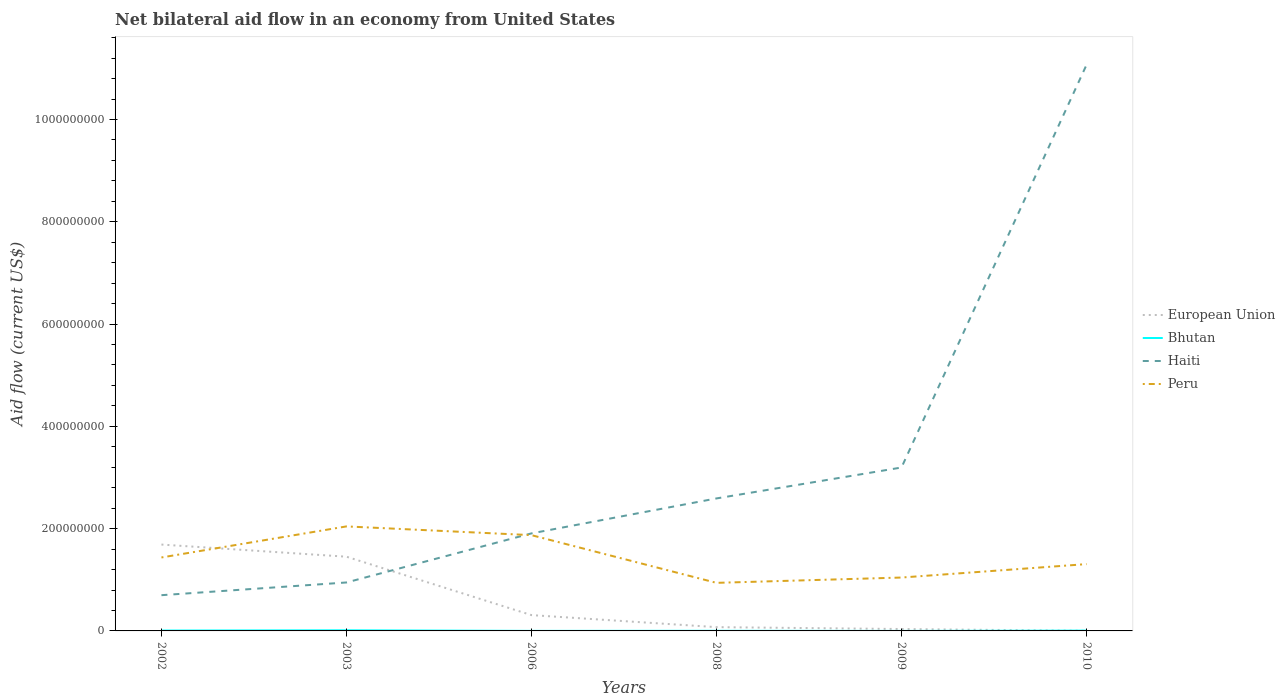Is the number of lines equal to the number of legend labels?
Your answer should be compact. Yes. Across all years, what is the maximum net bilateral aid flow in Peru?
Keep it short and to the point. 9.40e+07. What is the total net bilateral aid flow in European Union in the graph?
Make the answer very short. 1.38e+08. What is the difference between the highest and the second highest net bilateral aid flow in European Union?
Offer a very short reply. 1.69e+08. Is the net bilateral aid flow in Bhutan strictly greater than the net bilateral aid flow in European Union over the years?
Provide a short and direct response. No. How many years are there in the graph?
Keep it short and to the point. 6. Are the values on the major ticks of Y-axis written in scientific E-notation?
Make the answer very short. No. Does the graph contain any zero values?
Your answer should be very brief. No. How many legend labels are there?
Make the answer very short. 4. How are the legend labels stacked?
Give a very brief answer. Vertical. What is the title of the graph?
Your answer should be compact. Net bilateral aid flow in an economy from United States. Does "Hong Kong" appear as one of the legend labels in the graph?
Give a very brief answer. No. What is the label or title of the X-axis?
Give a very brief answer. Years. What is the label or title of the Y-axis?
Offer a very short reply. Aid flow (current US$). What is the Aid flow (current US$) in European Union in 2002?
Provide a short and direct response. 1.69e+08. What is the Aid flow (current US$) in Bhutan in 2002?
Ensure brevity in your answer.  7.30e+05. What is the Aid flow (current US$) of Haiti in 2002?
Give a very brief answer. 6.99e+07. What is the Aid flow (current US$) of Peru in 2002?
Provide a short and direct response. 1.44e+08. What is the Aid flow (current US$) of European Union in 2003?
Your answer should be compact. 1.45e+08. What is the Aid flow (current US$) of Bhutan in 2003?
Provide a short and direct response. 1.22e+06. What is the Aid flow (current US$) of Haiti in 2003?
Your answer should be compact. 9.47e+07. What is the Aid flow (current US$) in Peru in 2003?
Offer a terse response. 2.04e+08. What is the Aid flow (current US$) of European Union in 2006?
Your answer should be compact. 3.09e+07. What is the Aid flow (current US$) in Haiti in 2006?
Your answer should be compact. 1.91e+08. What is the Aid flow (current US$) of Peru in 2006?
Provide a succinct answer. 1.87e+08. What is the Aid flow (current US$) in European Union in 2008?
Your answer should be compact. 7.39e+06. What is the Aid flow (current US$) in Bhutan in 2008?
Your response must be concise. 2.40e+05. What is the Aid flow (current US$) in Haiti in 2008?
Keep it short and to the point. 2.59e+08. What is the Aid flow (current US$) in Peru in 2008?
Your response must be concise. 9.40e+07. What is the Aid flow (current US$) in European Union in 2009?
Your answer should be very brief. 3.70e+06. What is the Aid flow (current US$) of Haiti in 2009?
Offer a very short reply. 3.20e+08. What is the Aid flow (current US$) in Peru in 2009?
Your response must be concise. 1.04e+08. What is the Aid flow (current US$) of Bhutan in 2010?
Provide a short and direct response. 6.20e+05. What is the Aid flow (current US$) of Haiti in 2010?
Ensure brevity in your answer.  1.11e+09. What is the Aid flow (current US$) of Peru in 2010?
Make the answer very short. 1.31e+08. Across all years, what is the maximum Aid flow (current US$) of European Union?
Your response must be concise. 1.69e+08. Across all years, what is the maximum Aid flow (current US$) of Bhutan?
Provide a short and direct response. 1.22e+06. Across all years, what is the maximum Aid flow (current US$) of Haiti?
Make the answer very short. 1.11e+09. Across all years, what is the maximum Aid flow (current US$) of Peru?
Make the answer very short. 2.04e+08. Across all years, what is the minimum Aid flow (current US$) in Bhutan?
Ensure brevity in your answer.  10000. Across all years, what is the minimum Aid flow (current US$) of Haiti?
Provide a succinct answer. 6.99e+07. Across all years, what is the minimum Aid flow (current US$) in Peru?
Offer a terse response. 9.40e+07. What is the total Aid flow (current US$) in European Union in the graph?
Your answer should be very brief. 3.56e+08. What is the total Aid flow (current US$) in Bhutan in the graph?
Your answer should be compact. 2.90e+06. What is the total Aid flow (current US$) in Haiti in the graph?
Provide a succinct answer. 2.04e+09. What is the total Aid flow (current US$) in Peru in the graph?
Ensure brevity in your answer.  8.64e+08. What is the difference between the Aid flow (current US$) in European Union in 2002 and that in 2003?
Provide a succinct answer. 2.38e+07. What is the difference between the Aid flow (current US$) in Bhutan in 2002 and that in 2003?
Your answer should be compact. -4.90e+05. What is the difference between the Aid flow (current US$) of Haiti in 2002 and that in 2003?
Make the answer very short. -2.49e+07. What is the difference between the Aid flow (current US$) of Peru in 2002 and that in 2003?
Give a very brief answer. -6.07e+07. What is the difference between the Aid flow (current US$) of European Union in 2002 and that in 2006?
Make the answer very short. 1.38e+08. What is the difference between the Aid flow (current US$) in Bhutan in 2002 and that in 2006?
Your response must be concise. 6.50e+05. What is the difference between the Aid flow (current US$) in Haiti in 2002 and that in 2006?
Make the answer very short. -1.21e+08. What is the difference between the Aid flow (current US$) of Peru in 2002 and that in 2006?
Provide a succinct answer. -4.36e+07. What is the difference between the Aid flow (current US$) in European Union in 2002 and that in 2008?
Your answer should be very brief. 1.61e+08. What is the difference between the Aid flow (current US$) in Bhutan in 2002 and that in 2008?
Your response must be concise. 4.90e+05. What is the difference between the Aid flow (current US$) in Haiti in 2002 and that in 2008?
Offer a terse response. -1.89e+08. What is the difference between the Aid flow (current US$) of Peru in 2002 and that in 2008?
Ensure brevity in your answer.  4.96e+07. What is the difference between the Aid flow (current US$) in European Union in 2002 and that in 2009?
Give a very brief answer. 1.65e+08. What is the difference between the Aid flow (current US$) of Bhutan in 2002 and that in 2009?
Provide a succinct answer. 7.20e+05. What is the difference between the Aid flow (current US$) of Haiti in 2002 and that in 2009?
Your answer should be very brief. -2.50e+08. What is the difference between the Aid flow (current US$) of Peru in 2002 and that in 2009?
Make the answer very short. 3.92e+07. What is the difference between the Aid flow (current US$) of European Union in 2002 and that in 2010?
Offer a terse response. 1.69e+08. What is the difference between the Aid flow (current US$) in Bhutan in 2002 and that in 2010?
Provide a short and direct response. 1.10e+05. What is the difference between the Aid flow (current US$) in Haiti in 2002 and that in 2010?
Provide a short and direct response. -1.04e+09. What is the difference between the Aid flow (current US$) in Peru in 2002 and that in 2010?
Provide a short and direct response. 1.30e+07. What is the difference between the Aid flow (current US$) of European Union in 2003 and that in 2006?
Your answer should be compact. 1.14e+08. What is the difference between the Aid flow (current US$) in Bhutan in 2003 and that in 2006?
Your answer should be compact. 1.14e+06. What is the difference between the Aid flow (current US$) in Haiti in 2003 and that in 2006?
Provide a short and direct response. -9.60e+07. What is the difference between the Aid flow (current US$) of Peru in 2003 and that in 2006?
Your answer should be very brief. 1.71e+07. What is the difference between the Aid flow (current US$) of European Union in 2003 and that in 2008?
Provide a succinct answer. 1.38e+08. What is the difference between the Aid flow (current US$) of Bhutan in 2003 and that in 2008?
Keep it short and to the point. 9.80e+05. What is the difference between the Aid flow (current US$) of Haiti in 2003 and that in 2008?
Your response must be concise. -1.64e+08. What is the difference between the Aid flow (current US$) of Peru in 2003 and that in 2008?
Provide a succinct answer. 1.10e+08. What is the difference between the Aid flow (current US$) of European Union in 2003 and that in 2009?
Keep it short and to the point. 1.41e+08. What is the difference between the Aid flow (current US$) in Bhutan in 2003 and that in 2009?
Keep it short and to the point. 1.21e+06. What is the difference between the Aid flow (current US$) of Haiti in 2003 and that in 2009?
Offer a very short reply. -2.25e+08. What is the difference between the Aid flow (current US$) of Peru in 2003 and that in 2009?
Your answer should be compact. 1.00e+08. What is the difference between the Aid flow (current US$) in European Union in 2003 and that in 2010?
Provide a succinct answer. 1.45e+08. What is the difference between the Aid flow (current US$) of Bhutan in 2003 and that in 2010?
Your response must be concise. 6.00e+05. What is the difference between the Aid flow (current US$) of Haiti in 2003 and that in 2010?
Make the answer very short. -1.01e+09. What is the difference between the Aid flow (current US$) in Peru in 2003 and that in 2010?
Provide a succinct answer. 7.37e+07. What is the difference between the Aid flow (current US$) of European Union in 2006 and that in 2008?
Offer a very short reply. 2.36e+07. What is the difference between the Aid flow (current US$) in Haiti in 2006 and that in 2008?
Your answer should be very brief. -6.84e+07. What is the difference between the Aid flow (current US$) in Peru in 2006 and that in 2008?
Provide a short and direct response. 9.33e+07. What is the difference between the Aid flow (current US$) in European Union in 2006 and that in 2009?
Your response must be concise. 2.72e+07. What is the difference between the Aid flow (current US$) of Bhutan in 2006 and that in 2009?
Ensure brevity in your answer.  7.00e+04. What is the difference between the Aid flow (current US$) of Haiti in 2006 and that in 2009?
Give a very brief answer. -1.29e+08. What is the difference between the Aid flow (current US$) in Peru in 2006 and that in 2009?
Offer a terse response. 8.29e+07. What is the difference between the Aid flow (current US$) in European Union in 2006 and that in 2010?
Make the answer very short. 3.07e+07. What is the difference between the Aid flow (current US$) of Bhutan in 2006 and that in 2010?
Offer a terse response. -5.40e+05. What is the difference between the Aid flow (current US$) in Haiti in 2006 and that in 2010?
Ensure brevity in your answer.  -9.16e+08. What is the difference between the Aid flow (current US$) in Peru in 2006 and that in 2010?
Your answer should be compact. 5.66e+07. What is the difference between the Aid flow (current US$) in European Union in 2008 and that in 2009?
Give a very brief answer. 3.69e+06. What is the difference between the Aid flow (current US$) of Haiti in 2008 and that in 2009?
Provide a short and direct response. -6.05e+07. What is the difference between the Aid flow (current US$) of Peru in 2008 and that in 2009?
Give a very brief answer. -1.04e+07. What is the difference between the Aid flow (current US$) of European Union in 2008 and that in 2010?
Provide a succinct answer. 7.18e+06. What is the difference between the Aid flow (current US$) in Bhutan in 2008 and that in 2010?
Your response must be concise. -3.80e+05. What is the difference between the Aid flow (current US$) in Haiti in 2008 and that in 2010?
Make the answer very short. -8.48e+08. What is the difference between the Aid flow (current US$) of Peru in 2008 and that in 2010?
Offer a terse response. -3.66e+07. What is the difference between the Aid flow (current US$) in European Union in 2009 and that in 2010?
Make the answer very short. 3.49e+06. What is the difference between the Aid flow (current US$) of Bhutan in 2009 and that in 2010?
Your response must be concise. -6.10e+05. What is the difference between the Aid flow (current US$) in Haiti in 2009 and that in 2010?
Offer a very short reply. -7.87e+08. What is the difference between the Aid flow (current US$) in Peru in 2009 and that in 2010?
Your answer should be very brief. -2.62e+07. What is the difference between the Aid flow (current US$) in European Union in 2002 and the Aid flow (current US$) in Bhutan in 2003?
Provide a succinct answer. 1.68e+08. What is the difference between the Aid flow (current US$) in European Union in 2002 and the Aid flow (current US$) in Haiti in 2003?
Make the answer very short. 7.41e+07. What is the difference between the Aid flow (current US$) of European Union in 2002 and the Aid flow (current US$) of Peru in 2003?
Ensure brevity in your answer.  -3.55e+07. What is the difference between the Aid flow (current US$) in Bhutan in 2002 and the Aid flow (current US$) in Haiti in 2003?
Give a very brief answer. -9.40e+07. What is the difference between the Aid flow (current US$) of Bhutan in 2002 and the Aid flow (current US$) of Peru in 2003?
Ensure brevity in your answer.  -2.04e+08. What is the difference between the Aid flow (current US$) of Haiti in 2002 and the Aid flow (current US$) of Peru in 2003?
Give a very brief answer. -1.34e+08. What is the difference between the Aid flow (current US$) of European Union in 2002 and the Aid flow (current US$) of Bhutan in 2006?
Your answer should be very brief. 1.69e+08. What is the difference between the Aid flow (current US$) of European Union in 2002 and the Aid flow (current US$) of Haiti in 2006?
Offer a terse response. -2.18e+07. What is the difference between the Aid flow (current US$) in European Union in 2002 and the Aid flow (current US$) in Peru in 2006?
Ensure brevity in your answer.  -1.84e+07. What is the difference between the Aid flow (current US$) of Bhutan in 2002 and the Aid flow (current US$) of Haiti in 2006?
Provide a succinct answer. -1.90e+08. What is the difference between the Aid flow (current US$) of Bhutan in 2002 and the Aid flow (current US$) of Peru in 2006?
Offer a very short reply. -1.87e+08. What is the difference between the Aid flow (current US$) in Haiti in 2002 and the Aid flow (current US$) in Peru in 2006?
Provide a short and direct response. -1.17e+08. What is the difference between the Aid flow (current US$) of European Union in 2002 and the Aid flow (current US$) of Bhutan in 2008?
Provide a short and direct response. 1.69e+08. What is the difference between the Aid flow (current US$) of European Union in 2002 and the Aid flow (current US$) of Haiti in 2008?
Provide a succinct answer. -9.02e+07. What is the difference between the Aid flow (current US$) of European Union in 2002 and the Aid flow (current US$) of Peru in 2008?
Keep it short and to the point. 7.49e+07. What is the difference between the Aid flow (current US$) in Bhutan in 2002 and the Aid flow (current US$) in Haiti in 2008?
Your response must be concise. -2.58e+08. What is the difference between the Aid flow (current US$) in Bhutan in 2002 and the Aid flow (current US$) in Peru in 2008?
Your answer should be very brief. -9.33e+07. What is the difference between the Aid flow (current US$) of Haiti in 2002 and the Aid flow (current US$) of Peru in 2008?
Provide a short and direct response. -2.41e+07. What is the difference between the Aid flow (current US$) in European Union in 2002 and the Aid flow (current US$) in Bhutan in 2009?
Your answer should be very brief. 1.69e+08. What is the difference between the Aid flow (current US$) of European Union in 2002 and the Aid flow (current US$) of Haiti in 2009?
Offer a terse response. -1.51e+08. What is the difference between the Aid flow (current US$) in European Union in 2002 and the Aid flow (current US$) in Peru in 2009?
Make the answer very short. 6.45e+07. What is the difference between the Aid flow (current US$) in Bhutan in 2002 and the Aid flow (current US$) in Haiti in 2009?
Ensure brevity in your answer.  -3.19e+08. What is the difference between the Aid flow (current US$) in Bhutan in 2002 and the Aid flow (current US$) in Peru in 2009?
Your response must be concise. -1.04e+08. What is the difference between the Aid flow (current US$) of Haiti in 2002 and the Aid flow (current US$) of Peru in 2009?
Give a very brief answer. -3.45e+07. What is the difference between the Aid flow (current US$) in European Union in 2002 and the Aid flow (current US$) in Bhutan in 2010?
Offer a very short reply. 1.68e+08. What is the difference between the Aid flow (current US$) of European Union in 2002 and the Aid flow (current US$) of Haiti in 2010?
Offer a terse response. -9.38e+08. What is the difference between the Aid flow (current US$) of European Union in 2002 and the Aid flow (current US$) of Peru in 2010?
Keep it short and to the point. 3.82e+07. What is the difference between the Aid flow (current US$) of Bhutan in 2002 and the Aid flow (current US$) of Haiti in 2010?
Your answer should be very brief. -1.11e+09. What is the difference between the Aid flow (current US$) of Bhutan in 2002 and the Aid flow (current US$) of Peru in 2010?
Make the answer very short. -1.30e+08. What is the difference between the Aid flow (current US$) in Haiti in 2002 and the Aid flow (current US$) in Peru in 2010?
Your response must be concise. -6.08e+07. What is the difference between the Aid flow (current US$) in European Union in 2003 and the Aid flow (current US$) in Bhutan in 2006?
Ensure brevity in your answer.  1.45e+08. What is the difference between the Aid flow (current US$) of European Union in 2003 and the Aid flow (current US$) of Haiti in 2006?
Ensure brevity in your answer.  -4.56e+07. What is the difference between the Aid flow (current US$) of European Union in 2003 and the Aid flow (current US$) of Peru in 2006?
Offer a terse response. -4.21e+07. What is the difference between the Aid flow (current US$) in Bhutan in 2003 and the Aid flow (current US$) in Haiti in 2006?
Keep it short and to the point. -1.89e+08. What is the difference between the Aid flow (current US$) of Bhutan in 2003 and the Aid flow (current US$) of Peru in 2006?
Offer a terse response. -1.86e+08. What is the difference between the Aid flow (current US$) of Haiti in 2003 and the Aid flow (current US$) of Peru in 2006?
Your response must be concise. -9.25e+07. What is the difference between the Aid flow (current US$) of European Union in 2003 and the Aid flow (current US$) of Bhutan in 2008?
Your answer should be very brief. 1.45e+08. What is the difference between the Aid flow (current US$) of European Union in 2003 and the Aid flow (current US$) of Haiti in 2008?
Your response must be concise. -1.14e+08. What is the difference between the Aid flow (current US$) in European Union in 2003 and the Aid flow (current US$) in Peru in 2008?
Ensure brevity in your answer.  5.11e+07. What is the difference between the Aid flow (current US$) of Bhutan in 2003 and the Aid flow (current US$) of Haiti in 2008?
Offer a terse response. -2.58e+08. What is the difference between the Aid flow (current US$) of Bhutan in 2003 and the Aid flow (current US$) of Peru in 2008?
Your response must be concise. -9.28e+07. What is the difference between the Aid flow (current US$) of Haiti in 2003 and the Aid flow (current US$) of Peru in 2008?
Offer a very short reply. 7.40e+05. What is the difference between the Aid flow (current US$) in European Union in 2003 and the Aid flow (current US$) in Bhutan in 2009?
Provide a short and direct response. 1.45e+08. What is the difference between the Aid flow (current US$) in European Union in 2003 and the Aid flow (current US$) in Haiti in 2009?
Keep it short and to the point. -1.74e+08. What is the difference between the Aid flow (current US$) of European Union in 2003 and the Aid flow (current US$) of Peru in 2009?
Provide a short and direct response. 4.07e+07. What is the difference between the Aid flow (current US$) in Bhutan in 2003 and the Aid flow (current US$) in Haiti in 2009?
Ensure brevity in your answer.  -3.18e+08. What is the difference between the Aid flow (current US$) in Bhutan in 2003 and the Aid flow (current US$) in Peru in 2009?
Ensure brevity in your answer.  -1.03e+08. What is the difference between the Aid flow (current US$) of Haiti in 2003 and the Aid flow (current US$) of Peru in 2009?
Your answer should be very brief. -9.65e+06. What is the difference between the Aid flow (current US$) in European Union in 2003 and the Aid flow (current US$) in Bhutan in 2010?
Ensure brevity in your answer.  1.45e+08. What is the difference between the Aid flow (current US$) of European Union in 2003 and the Aid flow (current US$) of Haiti in 2010?
Your response must be concise. -9.62e+08. What is the difference between the Aid flow (current US$) of European Union in 2003 and the Aid flow (current US$) of Peru in 2010?
Your answer should be very brief. 1.45e+07. What is the difference between the Aid flow (current US$) of Bhutan in 2003 and the Aid flow (current US$) of Haiti in 2010?
Your answer should be very brief. -1.11e+09. What is the difference between the Aid flow (current US$) in Bhutan in 2003 and the Aid flow (current US$) in Peru in 2010?
Your answer should be compact. -1.29e+08. What is the difference between the Aid flow (current US$) in Haiti in 2003 and the Aid flow (current US$) in Peru in 2010?
Your answer should be very brief. -3.59e+07. What is the difference between the Aid flow (current US$) of European Union in 2006 and the Aid flow (current US$) of Bhutan in 2008?
Provide a short and direct response. 3.07e+07. What is the difference between the Aid flow (current US$) of European Union in 2006 and the Aid flow (current US$) of Haiti in 2008?
Make the answer very short. -2.28e+08. What is the difference between the Aid flow (current US$) of European Union in 2006 and the Aid flow (current US$) of Peru in 2008?
Offer a very short reply. -6.31e+07. What is the difference between the Aid flow (current US$) of Bhutan in 2006 and the Aid flow (current US$) of Haiti in 2008?
Your answer should be compact. -2.59e+08. What is the difference between the Aid flow (current US$) in Bhutan in 2006 and the Aid flow (current US$) in Peru in 2008?
Provide a short and direct response. -9.39e+07. What is the difference between the Aid flow (current US$) of Haiti in 2006 and the Aid flow (current US$) of Peru in 2008?
Keep it short and to the point. 9.67e+07. What is the difference between the Aid flow (current US$) in European Union in 2006 and the Aid flow (current US$) in Bhutan in 2009?
Provide a short and direct response. 3.09e+07. What is the difference between the Aid flow (current US$) of European Union in 2006 and the Aid flow (current US$) of Haiti in 2009?
Keep it short and to the point. -2.89e+08. What is the difference between the Aid flow (current US$) in European Union in 2006 and the Aid flow (current US$) in Peru in 2009?
Provide a short and direct response. -7.34e+07. What is the difference between the Aid flow (current US$) in Bhutan in 2006 and the Aid flow (current US$) in Haiti in 2009?
Provide a short and direct response. -3.19e+08. What is the difference between the Aid flow (current US$) in Bhutan in 2006 and the Aid flow (current US$) in Peru in 2009?
Make the answer very short. -1.04e+08. What is the difference between the Aid flow (current US$) of Haiti in 2006 and the Aid flow (current US$) of Peru in 2009?
Keep it short and to the point. 8.63e+07. What is the difference between the Aid flow (current US$) in European Union in 2006 and the Aid flow (current US$) in Bhutan in 2010?
Your answer should be very brief. 3.03e+07. What is the difference between the Aid flow (current US$) of European Union in 2006 and the Aid flow (current US$) of Haiti in 2010?
Give a very brief answer. -1.08e+09. What is the difference between the Aid flow (current US$) in European Union in 2006 and the Aid flow (current US$) in Peru in 2010?
Give a very brief answer. -9.97e+07. What is the difference between the Aid flow (current US$) in Bhutan in 2006 and the Aid flow (current US$) in Haiti in 2010?
Give a very brief answer. -1.11e+09. What is the difference between the Aid flow (current US$) of Bhutan in 2006 and the Aid flow (current US$) of Peru in 2010?
Offer a very short reply. -1.31e+08. What is the difference between the Aid flow (current US$) in Haiti in 2006 and the Aid flow (current US$) in Peru in 2010?
Provide a short and direct response. 6.01e+07. What is the difference between the Aid flow (current US$) in European Union in 2008 and the Aid flow (current US$) in Bhutan in 2009?
Offer a terse response. 7.38e+06. What is the difference between the Aid flow (current US$) of European Union in 2008 and the Aid flow (current US$) of Haiti in 2009?
Make the answer very short. -3.12e+08. What is the difference between the Aid flow (current US$) in European Union in 2008 and the Aid flow (current US$) in Peru in 2009?
Offer a terse response. -9.70e+07. What is the difference between the Aid flow (current US$) in Bhutan in 2008 and the Aid flow (current US$) in Haiti in 2009?
Keep it short and to the point. -3.19e+08. What is the difference between the Aid flow (current US$) in Bhutan in 2008 and the Aid flow (current US$) in Peru in 2009?
Your answer should be compact. -1.04e+08. What is the difference between the Aid flow (current US$) of Haiti in 2008 and the Aid flow (current US$) of Peru in 2009?
Ensure brevity in your answer.  1.55e+08. What is the difference between the Aid flow (current US$) of European Union in 2008 and the Aid flow (current US$) of Bhutan in 2010?
Your response must be concise. 6.77e+06. What is the difference between the Aid flow (current US$) of European Union in 2008 and the Aid flow (current US$) of Haiti in 2010?
Provide a short and direct response. -1.10e+09. What is the difference between the Aid flow (current US$) in European Union in 2008 and the Aid flow (current US$) in Peru in 2010?
Your answer should be very brief. -1.23e+08. What is the difference between the Aid flow (current US$) of Bhutan in 2008 and the Aid flow (current US$) of Haiti in 2010?
Keep it short and to the point. -1.11e+09. What is the difference between the Aid flow (current US$) of Bhutan in 2008 and the Aid flow (current US$) of Peru in 2010?
Your answer should be very brief. -1.30e+08. What is the difference between the Aid flow (current US$) of Haiti in 2008 and the Aid flow (current US$) of Peru in 2010?
Ensure brevity in your answer.  1.28e+08. What is the difference between the Aid flow (current US$) in European Union in 2009 and the Aid flow (current US$) in Bhutan in 2010?
Your answer should be very brief. 3.08e+06. What is the difference between the Aid flow (current US$) in European Union in 2009 and the Aid flow (current US$) in Haiti in 2010?
Provide a succinct answer. -1.10e+09. What is the difference between the Aid flow (current US$) in European Union in 2009 and the Aid flow (current US$) in Peru in 2010?
Offer a terse response. -1.27e+08. What is the difference between the Aid flow (current US$) of Bhutan in 2009 and the Aid flow (current US$) of Haiti in 2010?
Make the answer very short. -1.11e+09. What is the difference between the Aid flow (current US$) in Bhutan in 2009 and the Aid flow (current US$) in Peru in 2010?
Ensure brevity in your answer.  -1.31e+08. What is the difference between the Aid flow (current US$) in Haiti in 2009 and the Aid flow (current US$) in Peru in 2010?
Ensure brevity in your answer.  1.89e+08. What is the average Aid flow (current US$) of European Union per year?
Keep it short and to the point. 5.94e+07. What is the average Aid flow (current US$) of Bhutan per year?
Provide a short and direct response. 4.83e+05. What is the average Aid flow (current US$) in Haiti per year?
Provide a short and direct response. 3.40e+08. What is the average Aid flow (current US$) in Peru per year?
Make the answer very short. 1.44e+08. In the year 2002, what is the difference between the Aid flow (current US$) of European Union and Aid flow (current US$) of Bhutan?
Keep it short and to the point. 1.68e+08. In the year 2002, what is the difference between the Aid flow (current US$) of European Union and Aid flow (current US$) of Haiti?
Offer a terse response. 9.90e+07. In the year 2002, what is the difference between the Aid flow (current US$) of European Union and Aid flow (current US$) of Peru?
Provide a succinct answer. 2.53e+07. In the year 2002, what is the difference between the Aid flow (current US$) of Bhutan and Aid flow (current US$) of Haiti?
Offer a very short reply. -6.92e+07. In the year 2002, what is the difference between the Aid flow (current US$) in Bhutan and Aid flow (current US$) in Peru?
Provide a succinct answer. -1.43e+08. In the year 2002, what is the difference between the Aid flow (current US$) in Haiti and Aid flow (current US$) in Peru?
Ensure brevity in your answer.  -7.37e+07. In the year 2003, what is the difference between the Aid flow (current US$) in European Union and Aid flow (current US$) in Bhutan?
Ensure brevity in your answer.  1.44e+08. In the year 2003, what is the difference between the Aid flow (current US$) of European Union and Aid flow (current US$) of Haiti?
Offer a very short reply. 5.04e+07. In the year 2003, what is the difference between the Aid flow (current US$) in European Union and Aid flow (current US$) in Peru?
Ensure brevity in your answer.  -5.92e+07. In the year 2003, what is the difference between the Aid flow (current US$) of Bhutan and Aid flow (current US$) of Haiti?
Provide a succinct answer. -9.35e+07. In the year 2003, what is the difference between the Aid flow (current US$) in Bhutan and Aid flow (current US$) in Peru?
Offer a terse response. -2.03e+08. In the year 2003, what is the difference between the Aid flow (current US$) of Haiti and Aid flow (current US$) of Peru?
Make the answer very short. -1.10e+08. In the year 2006, what is the difference between the Aid flow (current US$) in European Union and Aid flow (current US$) in Bhutan?
Your response must be concise. 3.09e+07. In the year 2006, what is the difference between the Aid flow (current US$) of European Union and Aid flow (current US$) of Haiti?
Your answer should be compact. -1.60e+08. In the year 2006, what is the difference between the Aid flow (current US$) of European Union and Aid flow (current US$) of Peru?
Make the answer very short. -1.56e+08. In the year 2006, what is the difference between the Aid flow (current US$) in Bhutan and Aid flow (current US$) in Haiti?
Provide a succinct answer. -1.91e+08. In the year 2006, what is the difference between the Aid flow (current US$) of Bhutan and Aid flow (current US$) of Peru?
Give a very brief answer. -1.87e+08. In the year 2006, what is the difference between the Aid flow (current US$) in Haiti and Aid flow (current US$) in Peru?
Your answer should be compact. 3.45e+06. In the year 2008, what is the difference between the Aid flow (current US$) in European Union and Aid flow (current US$) in Bhutan?
Make the answer very short. 7.15e+06. In the year 2008, what is the difference between the Aid flow (current US$) of European Union and Aid flow (current US$) of Haiti?
Your answer should be very brief. -2.52e+08. In the year 2008, what is the difference between the Aid flow (current US$) of European Union and Aid flow (current US$) of Peru?
Give a very brief answer. -8.66e+07. In the year 2008, what is the difference between the Aid flow (current US$) of Bhutan and Aid flow (current US$) of Haiti?
Give a very brief answer. -2.59e+08. In the year 2008, what is the difference between the Aid flow (current US$) of Bhutan and Aid flow (current US$) of Peru?
Provide a short and direct response. -9.38e+07. In the year 2008, what is the difference between the Aid flow (current US$) in Haiti and Aid flow (current US$) in Peru?
Ensure brevity in your answer.  1.65e+08. In the year 2009, what is the difference between the Aid flow (current US$) of European Union and Aid flow (current US$) of Bhutan?
Keep it short and to the point. 3.69e+06. In the year 2009, what is the difference between the Aid flow (current US$) of European Union and Aid flow (current US$) of Haiti?
Ensure brevity in your answer.  -3.16e+08. In the year 2009, what is the difference between the Aid flow (current US$) of European Union and Aid flow (current US$) of Peru?
Your answer should be compact. -1.01e+08. In the year 2009, what is the difference between the Aid flow (current US$) of Bhutan and Aid flow (current US$) of Haiti?
Offer a terse response. -3.20e+08. In the year 2009, what is the difference between the Aid flow (current US$) in Bhutan and Aid flow (current US$) in Peru?
Ensure brevity in your answer.  -1.04e+08. In the year 2009, what is the difference between the Aid flow (current US$) of Haiti and Aid flow (current US$) of Peru?
Your answer should be compact. 2.15e+08. In the year 2010, what is the difference between the Aid flow (current US$) in European Union and Aid flow (current US$) in Bhutan?
Your answer should be very brief. -4.10e+05. In the year 2010, what is the difference between the Aid flow (current US$) in European Union and Aid flow (current US$) in Haiti?
Ensure brevity in your answer.  -1.11e+09. In the year 2010, what is the difference between the Aid flow (current US$) of European Union and Aid flow (current US$) of Peru?
Offer a very short reply. -1.30e+08. In the year 2010, what is the difference between the Aid flow (current US$) in Bhutan and Aid flow (current US$) in Haiti?
Provide a succinct answer. -1.11e+09. In the year 2010, what is the difference between the Aid flow (current US$) of Bhutan and Aid flow (current US$) of Peru?
Keep it short and to the point. -1.30e+08. In the year 2010, what is the difference between the Aid flow (current US$) in Haiti and Aid flow (current US$) in Peru?
Provide a succinct answer. 9.76e+08. What is the ratio of the Aid flow (current US$) in European Union in 2002 to that in 2003?
Offer a very short reply. 1.16. What is the ratio of the Aid flow (current US$) in Bhutan in 2002 to that in 2003?
Your response must be concise. 0.6. What is the ratio of the Aid flow (current US$) in Haiti in 2002 to that in 2003?
Offer a terse response. 0.74. What is the ratio of the Aid flow (current US$) in Peru in 2002 to that in 2003?
Provide a succinct answer. 0.7. What is the ratio of the Aid flow (current US$) of European Union in 2002 to that in 2006?
Give a very brief answer. 5.46. What is the ratio of the Aid flow (current US$) of Bhutan in 2002 to that in 2006?
Ensure brevity in your answer.  9.12. What is the ratio of the Aid flow (current US$) of Haiti in 2002 to that in 2006?
Offer a terse response. 0.37. What is the ratio of the Aid flow (current US$) in Peru in 2002 to that in 2006?
Make the answer very short. 0.77. What is the ratio of the Aid flow (current US$) of European Union in 2002 to that in 2008?
Make the answer very short. 22.85. What is the ratio of the Aid flow (current US$) in Bhutan in 2002 to that in 2008?
Your answer should be very brief. 3.04. What is the ratio of the Aid flow (current US$) of Haiti in 2002 to that in 2008?
Ensure brevity in your answer.  0.27. What is the ratio of the Aid flow (current US$) in Peru in 2002 to that in 2008?
Your answer should be very brief. 1.53. What is the ratio of the Aid flow (current US$) in European Union in 2002 to that in 2009?
Provide a short and direct response. 45.64. What is the ratio of the Aid flow (current US$) of Bhutan in 2002 to that in 2009?
Give a very brief answer. 73. What is the ratio of the Aid flow (current US$) of Haiti in 2002 to that in 2009?
Ensure brevity in your answer.  0.22. What is the ratio of the Aid flow (current US$) in Peru in 2002 to that in 2009?
Keep it short and to the point. 1.38. What is the ratio of the Aid flow (current US$) in European Union in 2002 to that in 2010?
Keep it short and to the point. 804.19. What is the ratio of the Aid flow (current US$) of Bhutan in 2002 to that in 2010?
Ensure brevity in your answer.  1.18. What is the ratio of the Aid flow (current US$) of Haiti in 2002 to that in 2010?
Provide a succinct answer. 0.06. What is the ratio of the Aid flow (current US$) in Peru in 2002 to that in 2010?
Make the answer very short. 1.1. What is the ratio of the Aid flow (current US$) in European Union in 2003 to that in 2006?
Provide a short and direct response. 4.69. What is the ratio of the Aid flow (current US$) of Bhutan in 2003 to that in 2006?
Keep it short and to the point. 15.25. What is the ratio of the Aid flow (current US$) of Haiti in 2003 to that in 2006?
Provide a succinct answer. 0.5. What is the ratio of the Aid flow (current US$) in Peru in 2003 to that in 2006?
Your response must be concise. 1.09. What is the ratio of the Aid flow (current US$) of European Union in 2003 to that in 2008?
Offer a very short reply. 19.64. What is the ratio of the Aid flow (current US$) in Bhutan in 2003 to that in 2008?
Ensure brevity in your answer.  5.08. What is the ratio of the Aid flow (current US$) of Haiti in 2003 to that in 2008?
Your response must be concise. 0.37. What is the ratio of the Aid flow (current US$) in Peru in 2003 to that in 2008?
Offer a terse response. 2.17. What is the ratio of the Aid flow (current US$) of European Union in 2003 to that in 2009?
Your answer should be compact. 39.22. What is the ratio of the Aid flow (current US$) in Bhutan in 2003 to that in 2009?
Offer a very short reply. 122. What is the ratio of the Aid flow (current US$) in Haiti in 2003 to that in 2009?
Your answer should be compact. 0.3. What is the ratio of the Aid flow (current US$) of Peru in 2003 to that in 2009?
Make the answer very short. 1.96. What is the ratio of the Aid flow (current US$) in European Union in 2003 to that in 2010?
Provide a short and direct response. 691.1. What is the ratio of the Aid flow (current US$) in Bhutan in 2003 to that in 2010?
Provide a short and direct response. 1.97. What is the ratio of the Aid flow (current US$) of Haiti in 2003 to that in 2010?
Offer a terse response. 0.09. What is the ratio of the Aid flow (current US$) of Peru in 2003 to that in 2010?
Give a very brief answer. 1.56. What is the ratio of the Aid flow (current US$) in European Union in 2006 to that in 2008?
Your response must be concise. 4.19. What is the ratio of the Aid flow (current US$) of Bhutan in 2006 to that in 2008?
Ensure brevity in your answer.  0.33. What is the ratio of the Aid flow (current US$) in Haiti in 2006 to that in 2008?
Provide a succinct answer. 0.74. What is the ratio of the Aid flow (current US$) in Peru in 2006 to that in 2008?
Offer a terse response. 1.99. What is the ratio of the Aid flow (current US$) of European Union in 2006 to that in 2009?
Your response must be concise. 8.36. What is the ratio of the Aid flow (current US$) of Bhutan in 2006 to that in 2009?
Your response must be concise. 8. What is the ratio of the Aid flow (current US$) in Haiti in 2006 to that in 2009?
Your answer should be very brief. 0.6. What is the ratio of the Aid flow (current US$) in Peru in 2006 to that in 2009?
Your answer should be very brief. 1.79. What is the ratio of the Aid flow (current US$) of European Union in 2006 to that in 2010?
Ensure brevity in your answer.  147.33. What is the ratio of the Aid flow (current US$) in Bhutan in 2006 to that in 2010?
Your answer should be very brief. 0.13. What is the ratio of the Aid flow (current US$) of Haiti in 2006 to that in 2010?
Offer a terse response. 0.17. What is the ratio of the Aid flow (current US$) of Peru in 2006 to that in 2010?
Ensure brevity in your answer.  1.43. What is the ratio of the Aid flow (current US$) of European Union in 2008 to that in 2009?
Your answer should be very brief. 2. What is the ratio of the Aid flow (current US$) of Haiti in 2008 to that in 2009?
Give a very brief answer. 0.81. What is the ratio of the Aid flow (current US$) in Peru in 2008 to that in 2009?
Provide a short and direct response. 0.9. What is the ratio of the Aid flow (current US$) in European Union in 2008 to that in 2010?
Provide a short and direct response. 35.19. What is the ratio of the Aid flow (current US$) of Bhutan in 2008 to that in 2010?
Keep it short and to the point. 0.39. What is the ratio of the Aid flow (current US$) in Haiti in 2008 to that in 2010?
Ensure brevity in your answer.  0.23. What is the ratio of the Aid flow (current US$) in Peru in 2008 to that in 2010?
Offer a very short reply. 0.72. What is the ratio of the Aid flow (current US$) in European Union in 2009 to that in 2010?
Make the answer very short. 17.62. What is the ratio of the Aid flow (current US$) in Bhutan in 2009 to that in 2010?
Offer a terse response. 0.02. What is the ratio of the Aid flow (current US$) in Haiti in 2009 to that in 2010?
Provide a short and direct response. 0.29. What is the ratio of the Aid flow (current US$) in Peru in 2009 to that in 2010?
Your answer should be compact. 0.8. What is the difference between the highest and the second highest Aid flow (current US$) in European Union?
Your answer should be compact. 2.38e+07. What is the difference between the highest and the second highest Aid flow (current US$) of Bhutan?
Your answer should be compact. 4.90e+05. What is the difference between the highest and the second highest Aid flow (current US$) in Haiti?
Offer a very short reply. 7.87e+08. What is the difference between the highest and the second highest Aid flow (current US$) of Peru?
Keep it short and to the point. 1.71e+07. What is the difference between the highest and the lowest Aid flow (current US$) in European Union?
Ensure brevity in your answer.  1.69e+08. What is the difference between the highest and the lowest Aid flow (current US$) in Bhutan?
Make the answer very short. 1.21e+06. What is the difference between the highest and the lowest Aid flow (current US$) of Haiti?
Your answer should be compact. 1.04e+09. What is the difference between the highest and the lowest Aid flow (current US$) of Peru?
Keep it short and to the point. 1.10e+08. 